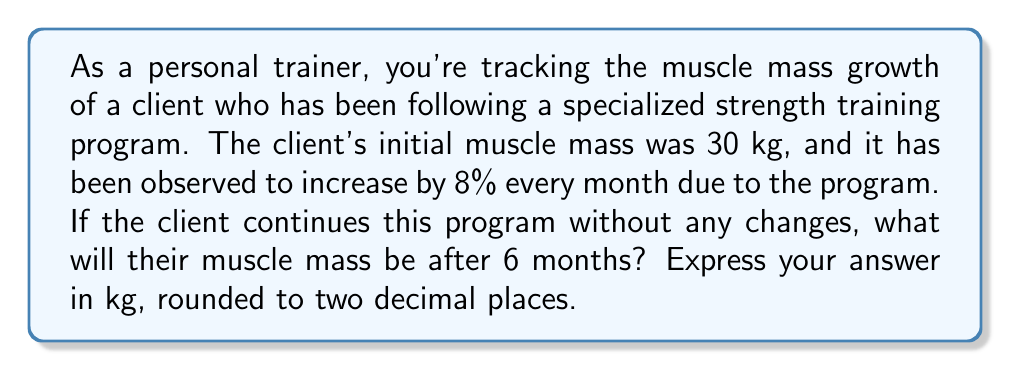What is the answer to this math problem? To solve this problem, we need to use the exponential growth formula:

$$A = P(1 + r)^t$$

Where:
$A$ = Final amount
$P$ = Initial principal amount
$r$ = Growth rate (as a decimal)
$t$ = Time period

Given:
$P = 30$ kg (initial muscle mass)
$r = 0.08$ (8% expressed as a decimal)
$t = 6$ months

Let's plug these values into the formula:

$$A = 30(1 + 0.08)^6$$

Now, let's solve this step-by-step:

1) First, calculate $(1 + 0.08)$:
   $1 + 0.08 = 1.08$

2) Now, we have:
   $$A = 30(1.08)^6$$

3) Calculate $1.08^6$:
   $1.08^6 \approx 1.5869$ (rounded to 4 decimal places)

4) Finally, multiply by 30:
   $30 \times 1.5869 \approx 47.607$ kg

5) Rounding to two decimal places:
   $47.61$ kg

Therefore, after 6 months, the client's muscle mass will be approximately 47.61 kg.
Answer: $47.61$ kg 